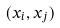Convert formula to latex. <formula><loc_0><loc_0><loc_500><loc_500>( x _ { i } , x _ { j } )</formula> 